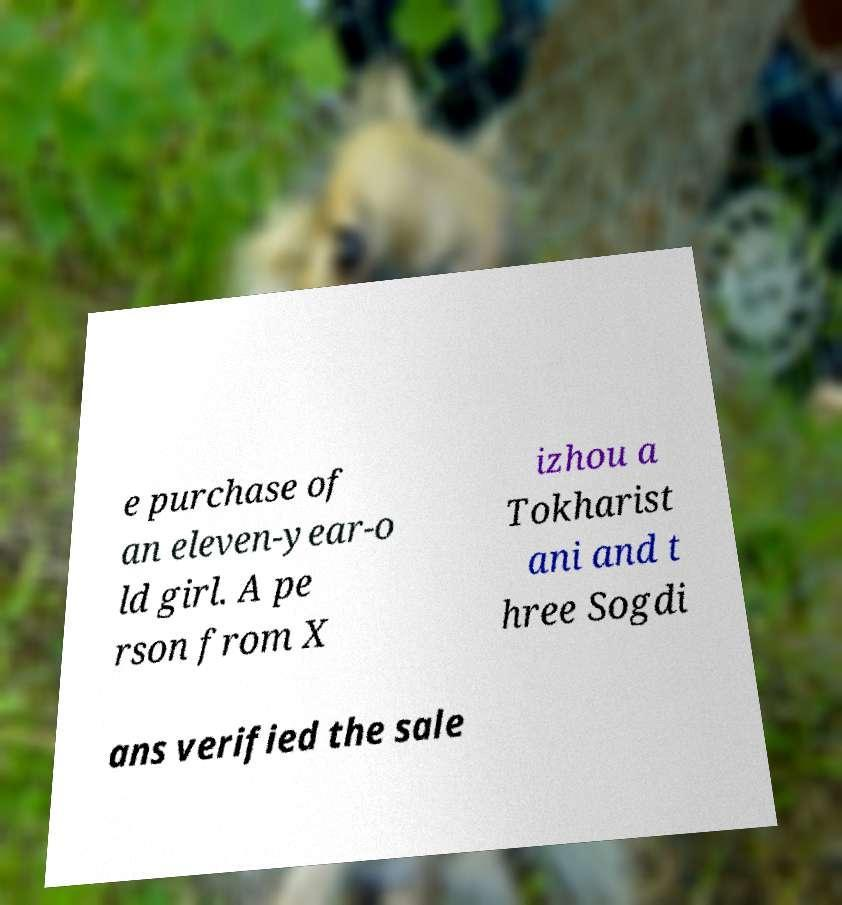Can you read and provide the text displayed in the image?This photo seems to have some interesting text. Can you extract and type it out for me? e purchase of an eleven-year-o ld girl. A pe rson from X izhou a Tokharist ani and t hree Sogdi ans verified the sale 